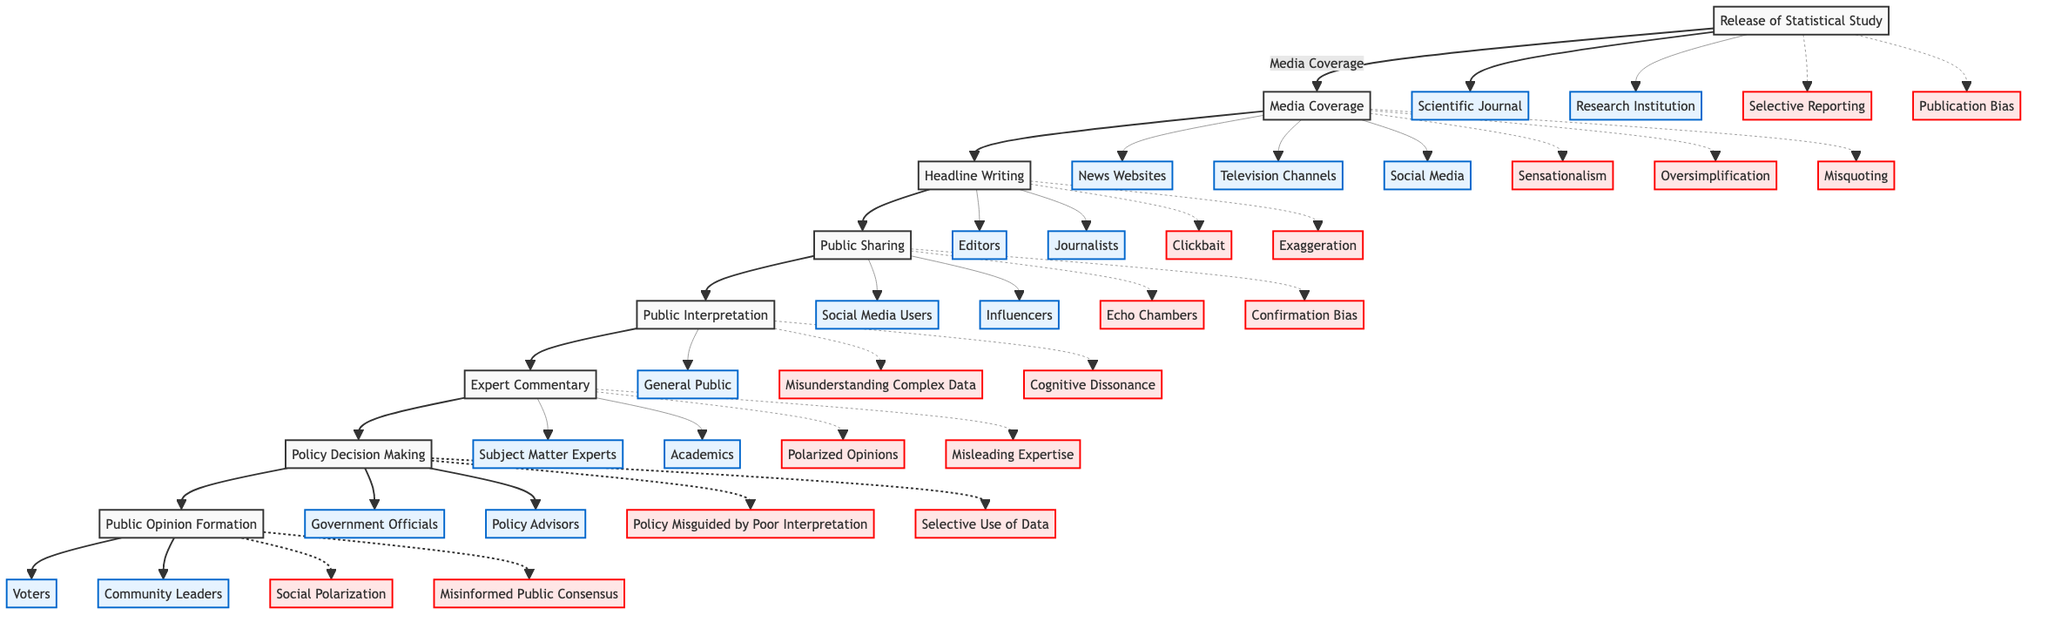What is the first step in the flowchart? The first step is labeled "Release of Statistical Study," indicating the starting point of the process.
Answer: Release of Statistical Study How many entities are listed under Media Coverage? There are three entities listed under "Media Coverage": News Websites, Television Channels, and Social Media.
Answer: 3 What potential issue is associated with Public Interpretation? There are two potential issues associated with "Public Interpretation": Misunderstanding Complex Data and Cognitive Dissonance.
Answer: Misunderstanding Complex Data, Cognitive Dissonance What step comes after Headline Writing? The next step after "Headline Writing" is "Public Sharing," reflecting the flow of information to the public.
Answer: Public Sharing Which entities can lead to Policy Decision Making? The entities that can lead to "Policy Decision Making" are Government Officials and Policy Advisors.
Answer: Government Officials, Policy Advisors What common issue is related to media's treatment of statistical studies? A common issue is "Sensationalism," which pertains to the tendency of media outlets to exaggerate or dramatize findings.
Answer: Sensationalism Why is Expert Commentary important in the flow? "Expert Commentary" is crucial as it provides a professional interpretation of the study; however, it can lead to Polarized Opinions and Misleading Expertise.
Answer: Provides interpretation, can lead to Polarized Opinions How does Public Sharing affect Public Interpretation? "Public Sharing" influences "Public Interpretation" by allowing individuals to access varied interpretations, which may lead to understanding or misunderstanding of the original data.
Answer: Influences understanding What potential issue arises at the Policy Decision Making stage? A potential issue at this stage is "Policy Misguided by Poor Interpretation," indicating that decisions may be based on inaccuracies.
Answer: Policy Misguided by Poor Interpretation 